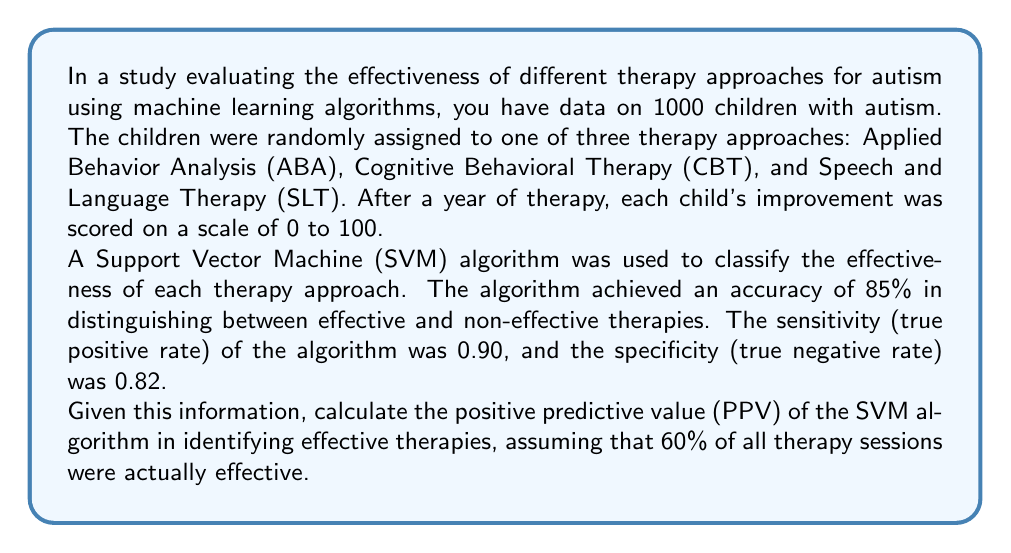Solve this math problem. To solve this problem, we need to use Bayes' theorem and the given information about the SVM algorithm's performance. Let's break it down step by step:

1. Define the variables:
   - E: Event that a therapy is actually effective
   - P: Event that the SVM predicts a therapy as effective

2. Given information:
   - Sensitivity (True Positive Rate): P(P|E) = 0.90
   - Specificity (True Negative Rate): P(not P|not E) = 0.82
   - Prevalence of effective therapies: P(E) = 0.60

3. Calculate P(not E), the probability of a therapy not being effective:
   P(not E) = 1 - P(E) = 1 - 0.60 = 0.40

4. Calculate P(P), the probability of the SVM predicting a therapy as effective:
   P(P) = P(P|E) * P(E) + P(P|not E) * P(not E)
   P(P|not E) = 1 - P(not P|not E) = 1 - 0.82 = 0.18
   P(P) = 0.90 * 0.60 + 0.18 * 0.40 = 0.54 + 0.072 = 0.612

5. Use Bayes' theorem to calculate the Positive Predictive Value (PPV):
   PPV = P(E|P) = (P(P|E) * P(E)) / P(P)
   
   $$PPV = \frac{0.90 * 0.60}{0.612} = \frac{0.54}{0.612} \approx 0.8824$$

6. Convert the result to a percentage:
   PPV ≈ 0.8824 * 100% = 88.24%
Answer: The positive predictive value (PPV) of the SVM algorithm in identifying effective therapies is approximately 88.24%. 